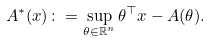Convert formula to latex. <formula><loc_0><loc_0><loc_500><loc_500>A ^ { * } ( x ) \colon = \sup _ { \theta \in \mathbb { R } ^ { n } } \theta ^ { \top } x - A ( \theta ) .</formula> 